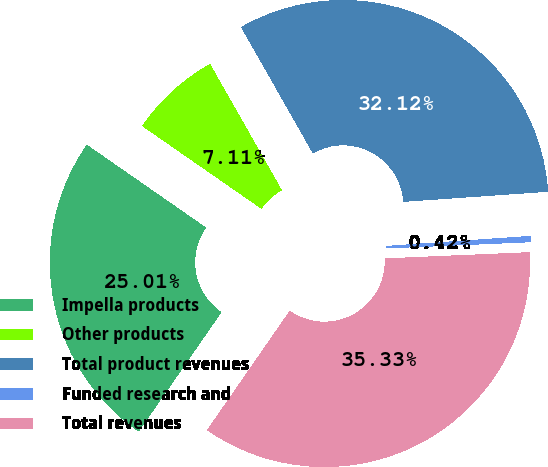<chart> <loc_0><loc_0><loc_500><loc_500><pie_chart><fcel>Impella products<fcel>Other products<fcel>Total product revenues<fcel>Funded research and<fcel>Total revenues<nl><fcel>25.01%<fcel>7.11%<fcel>32.12%<fcel>0.42%<fcel>35.33%<nl></chart> 